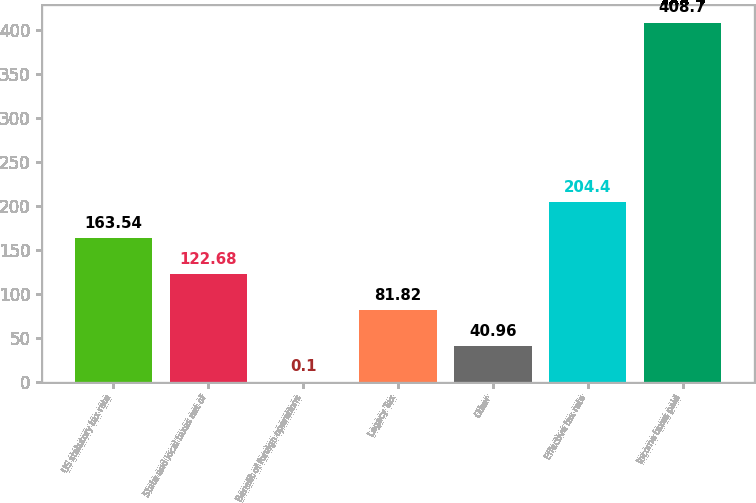Convert chart. <chart><loc_0><loc_0><loc_500><loc_500><bar_chart><fcel>US statutory tax rate<fcel>State and local taxes net of<fcel>Benefit of foreign operations<fcel>Legacy Tax<fcel>Other<fcel>Effective tax rate<fcel>Income taxes paid<nl><fcel>163.54<fcel>122.68<fcel>0.1<fcel>81.82<fcel>40.96<fcel>204.4<fcel>408.7<nl></chart> 